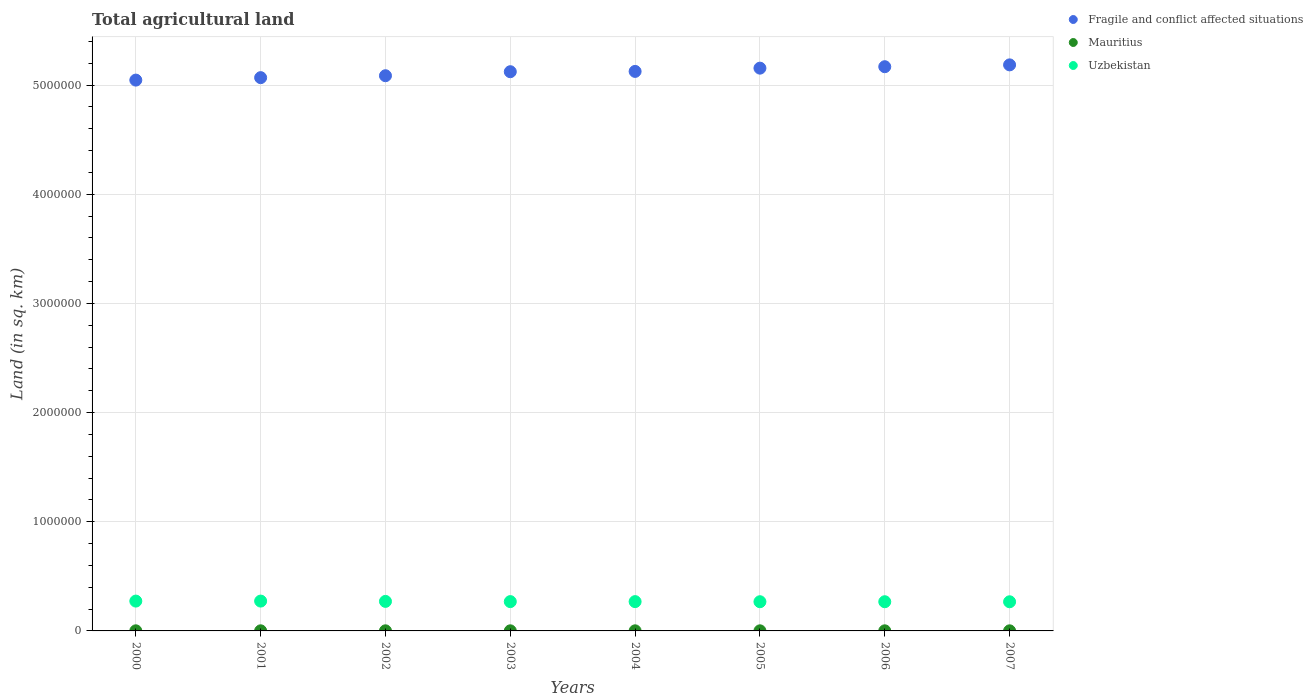How many different coloured dotlines are there?
Make the answer very short. 3. Is the number of dotlines equal to the number of legend labels?
Your answer should be very brief. Yes. What is the total agricultural land in Uzbekistan in 2000?
Offer a very short reply. 2.73e+05. Across all years, what is the maximum total agricultural land in Uzbekistan?
Provide a succinct answer. 2.73e+05. Across all years, what is the minimum total agricultural land in Mauritius?
Your answer should be compact. 920. What is the total total agricultural land in Uzbekistan in the graph?
Provide a short and direct response. 2.16e+06. What is the difference between the total agricultural land in Uzbekistan in 2001 and that in 2003?
Ensure brevity in your answer.  4900. What is the difference between the total agricultural land in Fragile and conflict affected situations in 2003 and the total agricultural land in Mauritius in 2005?
Your answer should be very brief. 5.12e+06. What is the average total agricultural land in Mauritius per year?
Keep it short and to the point. 977.5. In the year 2001, what is the difference between the total agricultural land in Fragile and conflict affected situations and total agricultural land in Mauritius?
Provide a succinct answer. 5.07e+06. In how many years, is the total agricultural land in Uzbekistan greater than 3800000 sq.km?
Offer a very short reply. 0. What is the ratio of the total agricultural land in Mauritius in 2004 to that in 2006?
Give a very brief answer. 1.04. Is the total agricultural land in Mauritius in 2000 less than that in 2006?
Ensure brevity in your answer.  No. Is the difference between the total agricultural land in Fragile and conflict affected situations in 2000 and 2001 greater than the difference between the total agricultural land in Mauritius in 2000 and 2001?
Offer a very short reply. No. What is the difference between the highest and the second highest total agricultural land in Fragile and conflict affected situations?
Your answer should be very brief. 1.68e+04. What is the difference between the highest and the lowest total agricultural land in Fragile and conflict affected situations?
Offer a terse response. 1.39e+05. Is the total agricultural land in Fragile and conflict affected situations strictly greater than the total agricultural land in Mauritius over the years?
Provide a succinct answer. Yes. How many years are there in the graph?
Provide a succinct answer. 8. Does the graph contain any zero values?
Your response must be concise. No. Where does the legend appear in the graph?
Give a very brief answer. Top right. How many legend labels are there?
Your answer should be very brief. 3. How are the legend labels stacked?
Make the answer very short. Vertical. What is the title of the graph?
Your response must be concise. Total agricultural land. Does "Kuwait" appear as one of the legend labels in the graph?
Ensure brevity in your answer.  No. What is the label or title of the X-axis?
Offer a very short reply. Years. What is the label or title of the Y-axis?
Make the answer very short. Land (in sq. km). What is the Land (in sq. km) in Fragile and conflict affected situations in 2000?
Give a very brief answer. 5.05e+06. What is the Land (in sq. km) in Mauritius in 2000?
Make the answer very short. 1010. What is the Land (in sq. km) of Uzbekistan in 2000?
Offer a terse response. 2.73e+05. What is the Land (in sq. km) of Fragile and conflict affected situations in 2001?
Ensure brevity in your answer.  5.07e+06. What is the Land (in sq. km) in Mauritius in 2001?
Your answer should be compact. 1020. What is the Land (in sq. km) of Uzbekistan in 2001?
Keep it short and to the point. 2.73e+05. What is the Land (in sq. km) of Fragile and conflict affected situations in 2002?
Provide a succinct answer. 5.09e+06. What is the Land (in sq. km) of Uzbekistan in 2002?
Ensure brevity in your answer.  2.70e+05. What is the Land (in sq. km) of Fragile and conflict affected situations in 2003?
Keep it short and to the point. 5.12e+06. What is the Land (in sq. km) in Mauritius in 2003?
Your response must be concise. 990. What is the Land (in sq. km) in Uzbekistan in 2003?
Your answer should be compact. 2.68e+05. What is the Land (in sq. km) of Fragile and conflict affected situations in 2004?
Keep it short and to the point. 5.12e+06. What is the Land (in sq. km) in Mauritius in 2004?
Offer a very short reply. 980. What is the Land (in sq. km) in Uzbekistan in 2004?
Make the answer very short. 2.68e+05. What is the Land (in sq. km) of Fragile and conflict affected situations in 2005?
Make the answer very short. 5.15e+06. What is the Land (in sq. km) of Mauritius in 2005?
Your answer should be very brief. 960. What is the Land (in sq. km) in Uzbekistan in 2005?
Make the answer very short. 2.67e+05. What is the Land (in sq. km) of Fragile and conflict affected situations in 2006?
Give a very brief answer. 5.17e+06. What is the Land (in sq. km) of Mauritius in 2006?
Your response must be concise. 940. What is the Land (in sq. km) in Uzbekistan in 2006?
Provide a succinct answer. 2.67e+05. What is the Land (in sq. km) of Fragile and conflict affected situations in 2007?
Your response must be concise. 5.18e+06. What is the Land (in sq. km) in Mauritius in 2007?
Your answer should be compact. 920. What is the Land (in sq. km) in Uzbekistan in 2007?
Offer a very short reply. 2.67e+05. Across all years, what is the maximum Land (in sq. km) of Fragile and conflict affected situations?
Your response must be concise. 5.18e+06. Across all years, what is the maximum Land (in sq. km) in Mauritius?
Offer a very short reply. 1020. Across all years, what is the maximum Land (in sq. km) in Uzbekistan?
Your answer should be very brief. 2.73e+05. Across all years, what is the minimum Land (in sq. km) in Fragile and conflict affected situations?
Give a very brief answer. 5.05e+06. Across all years, what is the minimum Land (in sq. km) in Mauritius?
Offer a very short reply. 920. Across all years, what is the minimum Land (in sq. km) in Uzbekistan?
Ensure brevity in your answer.  2.67e+05. What is the total Land (in sq. km) of Fragile and conflict affected situations in the graph?
Provide a short and direct response. 4.10e+07. What is the total Land (in sq. km) in Mauritius in the graph?
Provide a succinct answer. 7820. What is the total Land (in sq. km) of Uzbekistan in the graph?
Offer a terse response. 2.16e+06. What is the difference between the Land (in sq. km) in Fragile and conflict affected situations in 2000 and that in 2001?
Ensure brevity in your answer.  -2.24e+04. What is the difference between the Land (in sq. km) in Mauritius in 2000 and that in 2001?
Your answer should be compact. -10. What is the difference between the Land (in sq. km) in Fragile and conflict affected situations in 2000 and that in 2002?
Offer a terse response. -4.00e+04. What is the difference between the Land (in sq. km) in Mauritius in 2000 and that in 2002?
Offer a very short reply. 10. What is the difference between the Land (in sq. km) of Uzbekistan in 2000 and that in 2002?
Provide a short and direct response. 2790. What is the difference between the Land (in sq. km) of Fragile and conflict affected situations in 2000 and that in 2003?
Your answer should be very brief. -7.68e+04. What is the difference between the Land (in sq. km) in Uzbekistan in 2000 and that in 2003?
Offer a terse response. 4850. What is the difference between the Land (in sq. km) of Fragile and conflict affected situations in 2000 and that in 2004?
Provide a succinct answer. -7.96e+04. What is the difference between the Land (in sq. km) of Uzbekistan in 2000 and that in 2004?
Your answer should be compact. 4850. What is the difference between the Land (in sq. km) in Fragile and conflict affected situations in 2000 and that in 2005?
Make the answer very short. -1.09e+05. What is the difference between the Land (in sq. km) of Uzbekistan in 2000 and that in 2005?
Your answer should be very brief. 5850. What is the difference between the Land (in sq. km) in Fragile and conflict affected situations in 2000 and that in 2006?
Provide a succinct answer. -1.23e+05. What is the difference between the Land (in sq. km) in Uzbekistan in 2000 and that in 2006?
Your answer should be very brief. 5850. What is the difference between the Land (in sq. km) in Fragile and conflict affected situations in 2000 and that in 2007?
Offer a terse response. -1.39e+05. What is the difference between the Land (in sq. km) of Uzbekistan in 2000 and that in 2007?
Make the answer very short. 6350. What is the difference between the Land (in sq. km) of Fragile and conflict affected situations in 2001 and that in 2002?
Make the answer very short. -1.76e+04. What is the difference between the Land (in sq. km) in Mauritius in 2001 and that in 2002?
Keep it short and to the point. 20. What is the difference between the Land (in sq. km) of Uzbekistan in 2001 and that in 2002?
Your response must be concise. 2840. What is the difference between the Land (in sq. km) of Fragile and conflict affected situations in 2001 and that in 2003?
Your answer should be compact. -5.44e+04. What is the difference between the Land (in sq. km) of Uzbekistan in 2001 and that in 2003?
Make the answer very short. 4900. What is the difference between the Land (in sq. km) of Fragile and conflict affected situations in 2001 and that in 2004?
Give a very brief answer. -5.72e+04. What is the difference between the Land (in sq. km) in Uzbekistan in 2001 and that in 2004?
Your answer should be very brief. 4900. What is the difference between the Land (in sq. km) in Fragile and conflict affected situations in 2001 and that in 2005?
Your answer should be compact. -8.70e+04. What is the difference between the Land (in sq. km) of Uzbekistan in 2001 and that in 2005?
Your response must be concise. 5900. What is the difference between the Land (in sq. km) of Fragile and conflict affected situations in 2001 and that in 2006?
Offer a terse response. -1.00e+05. What is the difference between the Land (in sq. km) in Uzbekistan in 2001 and that in 2006?
Keep it short and to the point. 5900. What is the difference between the Land (in sq. km) of Fragile and conflict affected situations in 2001 and that in 2007?
Ensure brevity in your answer.  -1.17e+05. What is the difference between the Land (in sq. km) in Uzbekistan in 2001 and that in 2007?
Make the answer very short. 6400. What is the difference between the Land (in sq. km) of Fragile and conflict affected situations in 2002 and that in 2003?
Provide a short and direct response. -3.68e+04. What is the difference between the Land (in sq. km) in Mauritius in 2002 and that in 2003?
Offer a terse response. 10. What is the difference between the Land (in sq. km) of Uzbekistan in 2002 and that in 2003?
Provide a short and direct response. 2060. What is the difference between the Land (in sq. km) of Fragile and conflict affected situations in 2002 and that in 2004?
Your answer should be compact. -3.96e+04. What is the difference between the Land (in sq. km) in Uzbekistan in 2002 and that in 2004?
Provide a succinct answer. 2060. What is the difference between the Land (in sq. km) of Fragile and conflict affected situations in 2002 and that in 2005?
Ensure brevity in your answer.  -6.94e+04. What is the difference between the Land (in sq. km) in Mauritius in 2002 and that in 2005?
Keep it short and to the point. 40. What is the difference between the Land (in sq. km) in Uzbekistan in 2002 and that in 2005?
Your answer should be compact. 3060. What is the difference between the Land (in sq. km) of Fragile and conflict affected situations in 2002 and that in 2006?
Give a very brief answer. -8.26e+04. What is the difference between the Land (in sq. km) in Mauritius in 2002 and that in 2006?
Your answer should be very brief. 60. What is the difference between the Land (in sq. km) in Uzbekistan in 2002 and that in 2006?
Keep it short and to the point. 3060. What is the difference between the Land (in sq. km) of Fragile and conflict affected situations in 2002 and that in 2007?
Your response must be concise. -9.94e+04. What is the difference between the Land (in sq. km) of Mauritius in 2002 and that in 2007?
Make the answer very short. 80. What is the difference between the Land (in sq. km) of Uzbekistan in 2002 and that in 2007?
Your answer should be very brief. 3560. What is the difference between the Land (in sq. km) of Fragile and conflict affected situations in 2003 and that in 2004?
Make the answer very short. -2777.6. What is the difference between the Land (in sq. km) of Fragile and conflict affected situations in 2003 and that in 2005?
Keep it short and to the point. -3.26e+04. What is the difference between the Land (in sq. km) in Fragile and conflict affected situations in 2003 and that in 2006?
Give a very brief answer. -4.59e+04. What is the difference between the Land (in sq. km) in Mauritius in 2003 and that in 2006?
Give a very brief answer. 50. What is the difference between the Land (in sq. km) in Uzbekistan in 2003 and that in 2006?
Provide a succinct answer. 1000. What is the difference between the Land (in sq. km) in Fragile and conflict affected situations in 2003 and that in 2007?
Provide a short and direct response. -6.26e+04. What is the difference between the Land (in sq. km) in Uzbekistan in 2003 and that in 2007?
Offer a terse response. 1500. What is the difference between the Land (in sq. km) in Fragile and conflict affected situations in 2004 and that in 2005?
Offer a terse response. -2.99e+04. What is the difference between the Land (in sq. km) in Uzbekistan in 2004 and that in 2005?
Offer a terse response. 1000. What is the difference between the Land (in sq. km) in Fragile and conflict affected situations in 2004 and that in 2006?
Make the answer very short. -4.31e+04. What is the difference between the Land (in sq. km) in Uzbekistan in 2004 and that in 2006?
Offer a very short reply. 1000. What is the difference between the Land (in sq. km) of Fragile and conflict affected situations in 2004 and that in 2007?
Keep it short and to the point. -5.99e+04. What is the difference between the Land (in sq. km) of Uzbekistan in 2004 and that in 2007?
Your response must be concise. 1500. What is the difference between the Land (in sq. km) of Fragile and conflict affected situations in 2005 and that in 2006?
Keep it short and to the point. -1.32e+04. What is the difference between the Land (in sq. km) of Mauritius in 2005 and that in 2006?
Your answer should be very brief. 20. What is the difference between the Land (in sq. km) in Uzbekistan in 2005 and that in 2006?
Ensure brevity in your answer.  0. What is the difference between the Land (in sq. km) in Fragile and conflict affected situations in 2005 and that in 2007?
Offer a very short reply. -3.00e+04. What is the difference between the Land (in sq. km) in Mauritius in 2005 and that in 2007?
Ensure brevity in your answer.  40. What is the difference between the Land (in sq. km) of Uzbekistan in 2005 and that in 2007?
Keep it short and to the point. 500. What is the difference between the Land (in sq. km) in Fragile and conflict affected situations in 2006 and that in 2007?
Your answer should be very brief. -1.68e+04. What is the difference between the Land (in sq. km) in Mauritius in 2006 and that in 2007?
Make the answer very short. 20. What is the difference between the Land (in sq. km) of Uzbekistan in 2006 and that in 2007?
Make the answer very short. 500. What is the difference between the Land (in sq. km) of Fragile and conflict affected situations in 2000 and the Land (in sq. km) of Mauritius in 2001?
Your answer should be very brief. 5.04e+06. What is the difference between the Land (in sq. km) of Fragile and conflict affected situations in 2000 and the Land (in sq. km) of Uzbekistan in 2001?
Your answer should be very brief. 4.77e+06. What is the difference between the Land (in sq. km) in Mauritius in 2000 and the Land (in sq. km) in Uzbekistan in 2001?
Keep it short and to the point. -2.72e+05. What is the difference between the Land (in sq. km) of Fragile and conflict affected situations in 2000 and the Land (in sq. km) of Mauritius in 2002?
Offer a terse response. 5.04e+06. What is the difference between the Land (in sq. km) of Fragile and conflict affected situations in 2000 and the Land (in sq. km) of Uzbekistan in 2002?
Ensure brevity in your answer.  4.77e+06. What is the difference between the Land (in sq. km) of Mauritius in 2000 and the Land (in sq. km) of Uzbekistan in 2002?
Your response must be concise. -2.69e+05. What is the difference between the Land (in sq. km) in Fragile and conflict affected situations in 2000 and the Land (in sq. km) in Mauritius in 2003?
Provide a short and direct response. 5.04e+06. What is the difference between the Land (in sq. km) in Fragile and conflict affected situations in 2000 and the Land (in sq. km) in Uzbekistan in 2003?
Keep it short and to the point. 4.78e+06. What is the difference between the Land (in sq. km) of Mauritius in 2000 and the Land (in sq. km) of Uzbekistan in 2003?
Provide a short and direct response. -2.67e+05. What is the difference between the Land (in sq. km) in Fragile and conflict affected situations in 2000 and the Land (in sq. km) in Mauritius in 2004?
Your response must be concise. 5.04e+06. What is the difference between the Land (in sq. km) of Fragile and conflict affected situations in 2000 and the Land (in sq. km) of Uzbekistan in 2004?
Keep it short and to the point. 4.78e+06. What is the difference between the Land (in sq. km) of Mauritius in 2000 and the Land (in sq. km) of Uzbekistan in 2004?
Make the answer very short. -2.67e+05. What is the difference between the Land (in sq. km) in Fragile and conflict affected situations in 2000 and the Land (in sq. km) in Mauritius in 2005?
Give a very brief answer. 5.04e+06. What is the difference between the Land (in sq. km) of Fragile and conflict affected situations in 2000 and the Land (in sq. km) of Uzbekistan in 2005?
Your answer should be compact. 4.78e+06. What is the difference between the Land (in sq. km) in Mauritius in 2000 and the Land (in sq. km) in Uzbekistan in 2005?
Provide a short and direct response. -2.66e+05. What is the difference between the Land (in sq. km) in Fragile and conflict affected situations in 2000 and the Land (in sq. km) in Mauritius in 2006?
Ensure brevity in your answer.  5.04e+06. What is the difference between the Land (in sq. km) in Fragile and conflict affected situations in 2000 and the Land (in sq. km) in Uzbekistan in 2006?
Your answer should be compact. 4.78e+06. What is the difference between the Land (in sq. km) in Mauritius in 2000 and the Land (in sq. km) in Uzbekistan in 2006?
Your response must be concise. -2.66e+05. What is the difference between the Land (in sq. km) in Fragile and conflict affected situations in 2000 and the Land (in sq. km) in Mauritius in 2007?
Ensure brevity in your answer.  5.04e+06. What is the difference between the Land (in sq. km) in Fragile and conflict affected situations in 2000 and the Land (in sq. km) in Uzbekistan in 2007?
Provide a succinct answer. 4.78e+06. What is the difference between the Land (in sq. km) of Mauritius in 2000 and the Land (in sq. km) of Uzbekistan in 2007?
Offer a very short reply. -2.66e+05. What is the difference between the Land (in sq. km) in Fragile and conflict affected situations in 2001 and the Land (in sq. km) in Mauritius in 2002?
Give a very brief answer. 5.07e+06. What is the difference between the Land (in sq. km) in Fragile and conflict affected situations in 2001 and the Land (in sq. km) in Uzbekistan in 2002?
Provide a succinct answer. 4.80e+06. What is the difference between the Land (in sq. km) of Mauritius in 2001 and the Land (in sq. km) of Uzbekistan in 2002?
Offer a very short reply. -2.69e+05. What is the difference between the Land (in sq. km) of Fragile and conflict affected situations in 2001 and the Land (in sq. km) of Mauritius in 2003?
Your response must be concise. 5.07e+06. What is the difference between the Land (in sq. km) of Fragile and conflict affected situations in 2001 and the Land (in sq. km) of Uzbekistan in 2003?
Provide a succinct answer. 4.80e+06. What is the difference between the Land (in sq. km) in Mauritius in 2001 and the Land (in sq. km) in Uzbekistan in 2003?
Provide a short and direct response. -2.67e+05. What is the difference between the Land (in sq. km) of Fragile and conflict affected situations in 2001 and the Land (in sq. km) of Mauritius in 2004?
Provide a short and direct response. 5.07e+06. What is the difference between the Land (in sq. km) in Fragile and conflict affected situations in 2001 and the Land (in sq. km) in Uzbekistan in 2004?
Ensure brevity in your answer.  4.80e+06. What is the difference between the Land (in sq. km) in Mauritius in 2001 and the Land (in sq. km) in Uzbekistan in 2004?
Give a very brief answer. -2.67e+05. What is the difference between the Land (in sq. km) of Fragile and conflict affected situations in 2001 and the Land (in sq. km) of Mauritius in 2005?
Provide a succinct answer. 5.07e+06. What is the difference between the Land (in sq. km) of Fragile and conflict affected situations in 2001 and the Land (in sq. km) of Uzbekistan in 2005?
Give a very brief answer. 4.80e+06. What is the difference between the Land (in sq. km) in Mauritius in 2001 and the Land (in sq. km) in Uzbekistan in 2005?
Provide a short and direct response. -2.66e+05. What is the difference between the Land (in sq. km) in Fragile and conflict affected situations in 2001 and the Land (in sq. km) in Mauritius in 2006?
Your response must be concise. 5.07e+06. What is the difference between the Land (in sq. km) of Fragile and conflict affected situations in 2001 and the Land (in sq. km) of Uzbekistan in 2006?
Provide a short and direct response. 4.80e+06. What is the difference between the Land (in sq. km) of Mauritius in 2001 and the Land (in sq. km) of Uzbekistan in 2006?
Make the answer very short. -2.66e+05. What is the difference between the Land (in sq. km) of Fragile and conflict affected situations in 2001 and the Land (in sq. km) of Mauritius in 2007?
Keep it short and to the point. 5.07e+06. What is the difference between the Land (in sq. km) of Fragile and conflict affected situations in 2001 and the Land (in sq. km) of Uzbekistan in 2007?
Your answer should be very brief. 4.80e+06. What is the difference between the Land (in sq. km) of Mauritius in 2001 and the Land (in sq. km) of Uzbekistan in 2007?
Your answer should be very brief. -2.66e+05. What is the difference between the Land (in sq. km) of Fragile and conflict affected situations in 2002 and the Land (in sq. km) of Mauritius in 2003?
Your response must be concise. 5.08e+06. What is the difference between the Land (in sq. km) of Fragile and conflict affected situations in 2002 and the Land (in sq. km) of Uzbekistan in 2003?
Give a very brief answer. 4.82e+06. What is the difference between the Land (in sq. km) of Mauritius in 2002 and the Land (in sq. km) of Uzbekistan in 2003?
Give a very brief answer. -2.67e+05. What is the difference between the Land (in sq. km) in Fragile and conflict affected situations in 2002 and the Land (in sq. km) in Mauritius in 2004?
Offer a terse response. 5.08e+06. What is the difference between the Land (in sq. km) in Fragile and conflict affected situations in 2002 and the Land (in sq. km) in Uzbekistan in 2004?
Keep it short and to the point. 4.82e+06. What is the difference between the Land (in sq. km) of Mauritius in 2002 and the Land (in sq. km) of Uzbekistan in 2004?
Keep it short and to the point. -2.67e+05. What is the difference between the Land (in sq. km) of Fragile and conflict affected situations in 2002 and the Land (in sq. km) of Mauritius in 2005?
Your answer should be very brief. 5.08e+06. What is the difference between the Land (in sq. km) of Fragile and conflict affected situations in 2002 and the Land (in sq. km) of Uzbekistan in 2005?
Offer a terse response. 4.82e+06. What is the difference between the Land (in sq. km) of Mauritius in 2002 and the Land (in sq. km) of Uzbekistan in 2005?
Give a very brief answer. -2.66e+05. What is the difference between the Land (in sq. km) of Fragile and conflict affected situations in 2002 and the Land (in sq. km) of Mauritius in 2006?
Provide a short and direct response. 5.08e+06. What is the difference between the Land (in sq. km) in Fragile and conflict affected situations in 2002 and the Land (in sq. km) in Uzbekistan in 2006?
Your answer should be very brief. 4.82e+06. What is the difference between the Land (in sq. km) of Mauritius in 2002 and the Land (in sq. km) of Uzbekistan in 2006?
Provide a succinct answer. -2.66e+05. What is the difference between the Land (in sq. km) in Fragile and conflict affected situations in 2002 and the Land (in sq. km) in Mauritius in 2007?
Ensure brevity in your answer.  5.08e+06. What is the difference between the Land (in sq. km) of Fragile and conflict affected situations in 2002 and the Land (in sq. km) of Uzbekistan in 2007?
Ensure brevity in your answer.  4.82e+06. What is the difference between the Land (in sq. km) in Mauritius in 2002 and the Land (in sq. km) in Uzbekistan in 2007?
Your response must be concise. -2.66e+05. What is the difference between the Land (in sq. km) of Fragile and conflict affected situations in 2003 and the Land (in sq. km) of Mauritius in 2004?
Give a very brief answer. 5.12e+06. What is the difference between the Land (in sq. km) in Fragile and conflict affected situations in 2003 and the Land (in sq. km) in Uzbekistan in 2004?
Make the answer very short. 4.85e+06. What is the difference between the Land (in sq. km) of Mauritius in 2003 and the Land (in sq. km) of Uzbekistan in 2004?
Provide a short and direct response. -2.67e+05. What is the difference between the Land (in sq. km) in Fragile and conflict affected situations in 2003 and the Land (in sq. km) in Mauritius in 2005?
Your response must be concise. 5.12e+06. What is the difference between the Land (in sq. km) in Fragile and conflict affected situations in 2003 and the Land (in sq. km) in Uzbekistan in 2005?
Provide a short and direct response. 4.85e+06. What is the difference between the Land (in sq. km) in Mauritius in 2003 and the Land (in sq. km) in Uzbekistan in 2005?
Give a very brief answer. -2.66e+05. What is the difference between the Land (in sq. km) of Fragile and conflict affected situations in 2003 and the Land (in sq. km) of Mauritius in 2006?
Your answer should be compact. 5.12e+06. What is the difference between the Land (in sq. km) of Fragile and conflict affected situations in 2003 and the Land (in sq. km) of Uzbekistan in 2006?
Give a very brief answer. 4.85e+06. What is the difference between the Land (in sq. km) in Mauritius in 2003 and the Land (in sq. km) in Uzbekistan in 2006?
Your response must be concise. -2.66e+05. What is the difference between the Land (in sq. km) of Fragile and conflict affected situations in 2003 and the Land (in sq. km) of Mauritius in 2007?
Give a very brief answer. 5.12e+06. What is the difference between the Land (in sq. km) of Fragile and conflict affected situations in 2003 and the Land (in sq. km) of Uzbekistan in 2007?
Your response must be concise. 4.85e+06. What is the difference between the Land (in sq. km) of Mauritius in 2003 and the Land (in sq. km) of Uzbekistan in 2007?
Provide a succinct answer. -2.66e+05. What is the difference between the Land (in sq. km) in Fragile and conflict affected situations in 2004 and the Land (in sq. km) in Mauritius in 2005?
Your answer should be very brief. 5.12e+06. What is the difference between the Land (in sq. km) in Fragile and conflict affected situations in 2004 and the Land (in sq. km) in Uzbekistan in 2005?
Provide a succinct answer. 4.86e+06. What is the difference between the Land (in sq. km) of Mauritius in 2004 and the Land (in sq. km) of Uzbekistan in 2005?
Offer a very short reply. -2.66e+05. What is the difference between the Land (in sq. km) in Fragile and conflict affected situations in 2004 and the Land (in sq. km) in Mauritius in 2006?
Keep it short and to the point. 5.12e+06. What is the difference between the Land (in sq. km) of Fragile and conflict affected situations in 2004 and the Land (in sq. km) of Uzbekistan in 2006?
Provide a succinct answer. 4.86e+06. What is the difference between the Land (in sq. km) of Mauritius in 2004 and the Land (in sq. km) of Uzbekistan in 2006?
Make the answer very short. -2.66e+05. What is the difference between the Land (in sq. km) of Fragile and conflict affected situations in 2004 and the Land (in sq. km) of Mauritius in 2007?
Your answer should be compact. 5.12e+06. What is the difference between the Land (in sq. km) in Fragile and conflict affected situations in 2004 and the Land (in sq. km) in Uzbekistan in 2007?
Ensure brevity in your answer.  4.86e+06. What is the difference between the Land (in sq. km) of Mauritius in 2004 and the Land (in sq. km) of Uzbekistan in 2007?
Offer a terse response. -2.66e+05. What is the difference between the Land (in sq. km) of Fragile and conflict affected situations in 2005 and the Land (in sq. km) of Mauritius in 2006?
Provide a short and direct response. 5.15e+06. What is the difference between the Land (in sq. km) in Fragile and conflict affected situations in 2005 and the Land (in sq. km) in Uzbekistan in 2006?
Make the answer very short. 4.89e+06. What is the difference between the Land (in sq. km) of Mauritius in 2005 and the Land (in sq. km) of Uzbekistan in 2006?
Ensure brevity in your answer.  -2.66e+05. What is the difference between the Land (in sq. km) in Fragile and conflict affected situations in 2005 and the Land (in sq. km) in Mauritius in 2007?
Your answer should be very brief. 5.15e+06. What is the difference between the Land (in sq. km) of Fragile and conflict affected situations in 2005 and the Land (in sq. km) of Uzbekistan in 2007?
Keep it short and to the point. 4.89e+06. What is the difference between the Land (in sq. km) of Mauritius in 2005 and the Land (in sq. km) of Uzbekistan in 2007?
Your response must be concise. -2.66e+05. What is the difference between the Land (in sq. km) in Fragile and conflict affected situations in 2006 and the Land (in sq. km) in Mauritius in 2007?
Offer a very short reply. 5.17e+06. What is the difference between the Land (in sq. km) of Fragile and conflict affected situations in 2006 and the Land (in sq. km) of Uzbekistan in 2007?
Keep it short and to the point. 4.90e+06. What is the difference between the Land (in sq. km) of Mauritius in 2006 and the Land (in sq. km) of Uzbekistan in 2007?
Give a very brief answer. -2.66e+05. What is the average Land (in sq. km) in Fragile and conflict affected situations per year?
Your answer should be compact. 5.12e+06. What is the average Land (in sq. km) of Mauritius per year?
Ensure brevity in your answer.  977.5. What is the average Land (in sq. km) of Uzbekistan per year?
Keep it short and to the point. 2.69e+05. In the year 2000, what is the difference between the Land (in sq. km) of Fragile and conflict affected situations and Land (in sq. km) of Mauritius?
Give a very brief answer. 5.04e+06. In the year 2000, what is the difference between the Land (in sq. km) of Fragile and conflict affected situations and Land (in sq. km) of Uzbekistan?
Ensure brevity in your answer.  4.77e+06. In the year 2000, what is the difference between the Land (in sq. km) of Mauritius and Land (in sq. km) of Uzbekistan?
Give a very brief answer. -2.72e+05. In the year 2001, what is the difference between the Land (in sq. km) in Fragile and conflict affected situations and Land (in sq. km) in Mauritius?
Keep it short and to the point. 5.07e+06. In the year 2001, what is the difference between the Land (in sq. km) in Fragile and conflict affected situations and Land (in sq. km) in Uzbekistan?
Give a very brief answer. 4.79e+06. In the year 2001, what is the difference between the Land (in sq. km) of Mauritius and Land (in sq. km) of Uzbekistan?
Keep it short and to the point. -2.72e+05. In the year 2002, what is the difference between the Land (in sq. km) of Fragile and conflict affected situations and Land (in sq. km) of Mauritius?
Provide a succinct answer. 5.08e+06. In the year 2002, what is the difference between the Land (in sq. km) in Fragile and conflict affected situations and Land (in sq. km) in Uzbekistan?
Give a very brief answer. 4.81e+06. In the year 2002, what is the difference between the Land (in sq. km) of Mauritius and Land (in sq. km) of Uzbekistan?
Provide a succinct answer. -2.69e+05. In the year 2003, what is the difference between the Land (in sq. km) in Fragile and conflict affected situations and Land (in sq. km) in Mauritius?
Keep it short and to the point. 5.12e+06. In the year 2003, what is the difference between the Land (in sq. km) of Fragile and conflict affected situations and Land (in sq. km) of Uzbekistan?
Your answer should be compact. 4.85e+06. In the year 2003, what is the difference between the Land (in sq. km) in Mauritius and Land (in sq. km) in Uzbekistan?
Provide a succinct answer. -2.67e+05. In the year 2004, what is the difference between the Land (in sq. km) in Fragile and conflict affected situations and Land (in sq. km) in Mauritius?
Your answer should be very brief. 5.12e+06. In the year 2004, what is the difference between the Land (in sq. km) of Fragile and conflict affected situations and Land (in sq. km) of Uzbekistan?
Your answer should be compact. 4.86e+06. In the year 2004, what is the difference between the Land (in sq. km) of Mauritius and Land (in sq. km) of Uzbekistan?
Provide a short and direct response. -2.67e+05. In the year 2005, what is the difference between the Land (in sq. km) of Fragile and conflict affected situations and Land (in sq. km) of Mauritius?
Your answer should be compact. 5.15e+06. In the year 2005, what is the difference between the Land (in sq. km) in Fragile and conflict affected situations and Land (in sq. km) in Uzbekistan?
Give a very brief answer. 4.89e+06. In the year 2005, what is the difference between the Land (in sq. km) of Mauritius and Land (in sq. km) of Uzbekistan?
Give a very brief answer. -2.66e+05. In the year 2006, what is the difference between the Land (in sq. km) of Fragile and conflict affected situations and Land (in sq. km) of Mauritius?
Make the answer very short. 5.17e+06. In the year 2006, what is the difference between the Land (in sq. km) in Fragile and conflict affected situations and Land (in sq. km) in Uzbekistan?
Your answer should be very brief. 4.90e+06. In the year 2006, what is the difference between the Land (in sq. km) in Mauritius and Land (in sq. km) in Uzbekistan?
Offer a very short reply. -2.66e+05. In the year 2007, what is the difference between the Land (in sq. km) of Fragile and conflict affected situations and Land (in sq. km) of Mauritius?
Ensure brevity in your answer.  5.18e+06. In the year 2007, what is the difference between the Land (in sq. km) of Fragile and conflict affected situations and Land (in sq. km) of Uzbekistan?
Provide a short and direct response. 4.92e+06. In the year 2007, what is the difference between the Land (in sq. km) of Mauritius and Land (in sq. km) of Uzbekistan?
Offer a terse response. -2.66e+05. What is the ratio of the Land (in sq. km) in Fragile and conflict affected situations in 2000 to that in 2001?
Keep it short and to the point. 1. What is the ratio of the Land (in sq. km) of Mauritius in 2000 to that in 2001?
Give a very brief answer. 0.99. What is the ratio of the Land (in sq. km) of Uzbekistan in 2000 to that in 2001?
Your answer should be very brief. 1. What is the ratio of the Land (in sq. km) in Fragile and conflict affected situations in 2000 to that in 2002?
Provide a short and direct response. 0.99. What is the ratio of the Land (in sq. km) of Mauritius in 2000 to that in 2002?
Keep it short and to the point. 1.01. What is the ratio of the Land (in sq. km) in Uzbekistan in 2000 to that in 2002?
Your answer should be very brief. 1.01. What is the ratio of the Land (in sq. km) in Fragile and conflict affected situations in 2000 to that in 2003?
Your response must be concise. 0.98. What is the ratio of the Land (in sq. km) in Mauritius in 2000 to that in 2003?
Your answer should be very brief. 1.02. What is the ratio of the Land (in sq. km) in Uzbekistan in 2000 to that in 2003?
Offer a terse response. 1.02. What is the ratio of the Land (in sq. km) of Fragile and conflict affected situations in 2000 to that in 2004?
Provide a succinct answer. 0.98. What is the ratio of the Land (in sq. km) of Mauritius in 2000 to that in 2004?
Offer a terse response. 1.03. What is the ratio of the Land (in sq. km) of Uzbekistan in 2000 to that in 2004?
Your response must be concise. 1.02. What is the ratio of the Land (in sq. km) in Fragile and conflict affected situations in 2000 to that in 2005?
Your answer should be compact. 0.98. What is the ratio of the Land (in sq. km) of Mauritius in 2000 to that in 2005?
Provide a succinct answer. 1.05. What is the ratio of the Land (in sq. km) in Uzbekistan in 2000 to that in 2005?
Give a very brief answer. 1.02. What is the ratio of the Land (in sq. km) in Fragile and conflict affected situations in 2000 to that in 2006?
Make the answer very short. 0.98. What is the ratio of the Land (in sq. km) of Mauritius in 2000 to that in 2006?
Provide a short and direct response. 1.07. What is the ratio of the Land (in sq. km) in Uzbekistan in 2000 to that in 2006?
Keep it short and to the point. 1.02. What is the ratio of the Land (in sq. km) of Fragile and conflict affected situations in 2000 to that in 2007?
Ensure brevity in your answer.  0.97. What is the ratio of the Land (in sq. km) of Mauritius in 2000 to that in 2007?
Make the answer very short. 1.1. What is the ratio of the Land (in sq. km) of Uzbekistan in 2000 to that in 2007?
Ensure brevity in your answer.  1.02. What is the ratio of the Land (in sq. km) in Mauritius in 2001 to that in 2002?
Offer a very short reply. 1.02. What is the ratio of the Land (in sq. km) of Uzbekistan in 2001 to that in 2002?
Your answer should be compact. 1.01. What is the ratio of the Land (in sq. km) in Mauritius in 2001 to that in 2003?
Keep it short and to the point. 1.03. What is the ratio of the Land (in sq. km) of Uzbekistan in 2001 to that in 2003?
Your response must be concise. 1.02. What is the ratio of the Land (in sq. km) in Mauritius in 2001 to that in 2004?
Provide a short and direct response. 1.04. What is the ratio of the Land (in sq. km) of Uzbekistan in 2001 to that in 2004?
Provide a succinct answer. 1.02. What is the ratio of the Land (in sq. km) in Fragile and conflict affected situations in 2001 to that in 2005?
Provide a succinct answer. 0.98. What is the ratio of the Land (in sq. km) in Uzbekistan in 2001 to that in 2005?
Offer a very short reply. 1.02. What is the ratio of the Land (in sq. km) of Fragile and conflict affected situations in 2001 to that in 2006?
Your answer should be very brief. 0.98. What is the ratio of the Land (in sq. km) in Mauritius in 2001 to that in 2006?
Your response must be concise. 1.09. What is the ratio of the Land (in sq. km) of Uzbekistan in 2001 to that in 2006?
Provide a succinct answer. 1.02. What is the ratio of the Land (in sq. km) in Fragile and conflict affected situations in 2001 to that in 2007?
Your response must be concise. 0.98. What is the ratio of the Land (in sq. km) of Mauritius in 2001 to that in 2007?
Make the answer very short. 1.11. What is the ratio of the Land (in sq. km) of Uzbekistan in 2001 to that in 2007?
Keep it short and to the point. 1.02. What is the ratio of the Land (in sq. km) of Mauritius in 2002 to that in 2003?
Keep it short and to the point. 1.01. What is the ratio of the Land (in sq. km) in Uzbekistan in 2002 to that in 2003?
Offer a very short reply. 1.01. What is the ratio of the Land (in sq. km) of Fragile and conflict affected situations in 2002 to that in 2004?
Offer a very short reply. 0.99. What is the ratio of the Land (in sq. km) of Mauritius in 2002 to that in 2004?
Offer a very short reply. 1.02. What is the ratio of the Land (in sq. km) of Uzbekistan in 2002 to that in 2004?
Offer a very short reply. 1.01. What is the ratio of the Land (in sq. km) of Fragile and conflict affected situations in 2002 to that in 2005?
Make the answer very short. 0.99. What is the ratio of the Land (in sq. km) in Mauritius in 2002 to that in 2005?
Your response must be concise. 1.04. What is the ratio of the Land (in sq. km) of Uzbekistan in 2002 to that in 2005?
Your answer should be very brief. 1.01. What is the ratio of the Land (in sq. km) of Fragile and conflict affected situations in 2002 to that in 2006?
Make the answer very short. 0.98. What is the ratio of the Land (in sq. km) in Mauritius in 2002 to that in 2006?
Keep it short and to the point. 1.06. What is the ratio of the Land (in sq. km) of Uzbekistan in 2002 to that in 2006?
Keep it short and to the point. 1.01. What is the ratio of the Land (in sq. km) in Fragile and conflict affected situations in 2002 to that in 2007?
Offer a terse response. 0.98. What is the ratio of the Land (in sq. km) of Mauritius in 2002 to that in 2007?
Ensure brevity in your answer.  1.09. What is the ratio of the Land (in sq. km) of Uzbekistan in 2002 to that in 2007?
Your answer should be very brief. 1.01. What is the ratio of the Land (in sq. km) of Fragile and conflict affected situations in 2003 to that in 2004?
Offer a very short reply. 1. What is the ratio of the Land (in sq. km) in Mauritius in 2003 to that in 2004?
Ensure brevity in your answer.  1.01. What is the ratio of the Land (in sq. km) in Fragile and conflict affected situations in 2003 to that in 2005?
Your answer should be compact. 0.99. What is the ratio of the Land (in sq. km) of Mauritius in 2003 to that in 2005?
Ensure brevity in your answer.  1.03. What is the ratio of the Land (in sq. km) in Mauritius in 2003 to that in 2006?
Ensure brevity in your answer.  1.05. What is the ratio of the Land (in sq. km) of Uzbekistan in 2003 to that in 2006?
Give a very brief answer. 1. What is the ratio of the Land (in sq. km) of Fragile and conflict affected situations in 2003 to that in 2007?
Your response must be concise. 0.99. What is the ratio of the Land (in sq. km) in Mauritius in 2003 to that in 2007?
Ensure brevity in your answer.  1.08. What is the ratio of the Land (in sq. km) in Uzbekistan in 2003 to that in 2007?
Provide a short and direct response. 1.01. What is the ratio of the Land (in sq. km) of Mauritius in 2004 to that in 2005?
Give a very brief answer. 1.02. What is the ratio of the Land (in sq. km) of Mauritius in 2004 to that in 2006?
Give a very brief answer. 1.04. What is the ratio of the Land (in sq. km) in Fragile and conflict affected situations in 2004 to that in 2007?
Give a very brief answer. 0.99. What is the ratio of the Land (in sq. km) of Mauritius in 2004 to that in 2007?
Your answer should be compact. 1.07. What is the ratio of the Land (in sq. km) of Uzbekistan in 2004 to that in 2007?
Offer a terse response. 1.01. What is the ratio of the Land (in sq. km) of Fragile and conflict affected situations in 2005 to that in 2006?
Make the answer very short. 1. What is the ratio of the Land (in sq. km) of Mauritius in 2005 to that in 2006?
Offer a very short reply. 1.02. What is the ratio of the Land (in sq. km) of Fragile and conflict affected situations in 2005 to that in 2007?
Ensure brevity in your answer.  0.99. What is the ratio of the Land (in sq. km) of Mauritius in 2005 to that in 2007?
Offer a terse response. 1.04. What is the ratio of the Land (in sq. km) in Mauritius in 2006 to that in 2007?
Your answer should be compact. 1.02. What is the ratio of the Land (in sq. km) of Uzbekistan in 2006 to that in 2007?
Your answer should be very brief. 1. What is the difference between the highest and the second highest Land (in sq. km) of Fragile and conflict affected situations?
Your answer should be very brief. 1.68e+04. What is the difference between the highest and the second highest Land (in sq. km) in Uzbekistan?
Your answer should be very brief. 50. What is the difference between the highest and the lowest Land (in sq. km) in Fragile and conflict affected situations?
Provide a short and direct response. 1.39e+05. What is the difference between the highest and the lowest Land (in sq. km) in Mauritius?
Give a very brief answer. 100. What is the difference between the highest and the lowest Land (in sq. km) of Uzbekistan?
Your answer should be compact. 6400. 